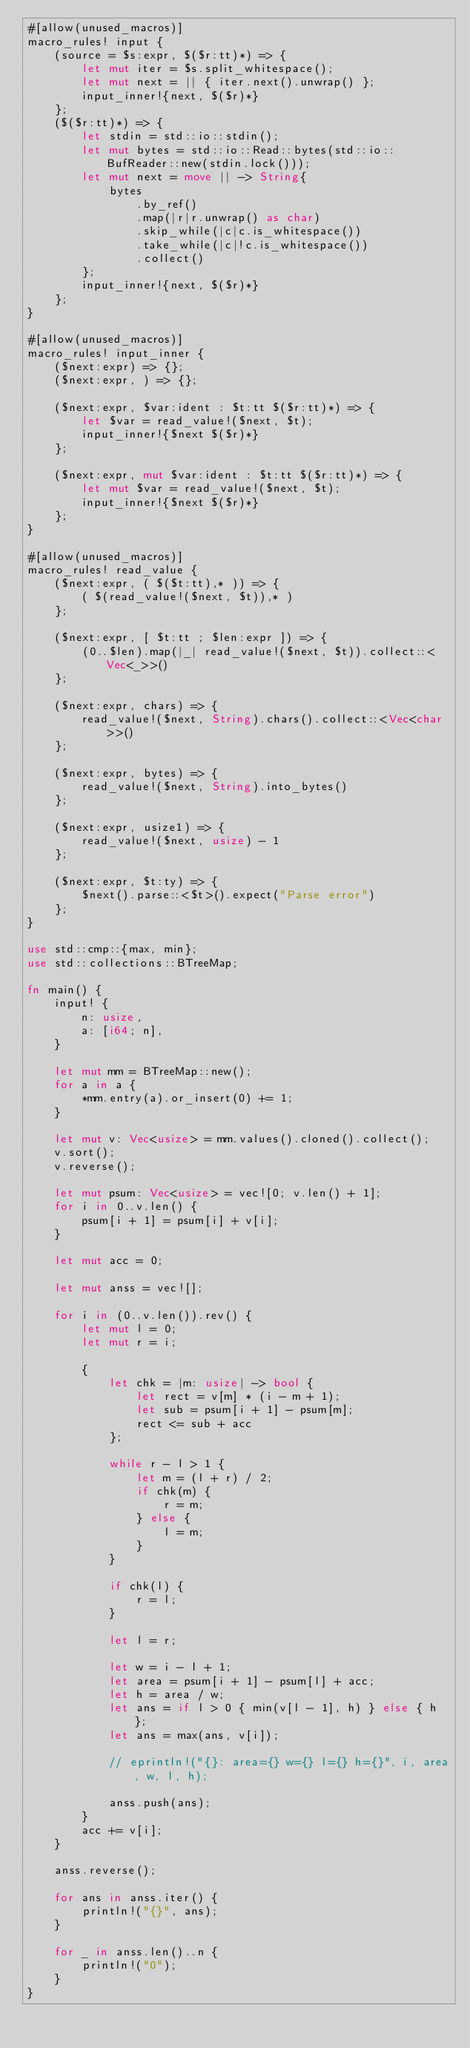<code> <loc_0><loc_0><loc_500><loc_500><_Rust_>#[allow(unused_macros)]
macro_rules! input {
    (source = $s:expr, $($r:tt)*) => {
        let mut iter = $s.split_whitespace();
        let mut next = || { iter.next().unwrap() };
        input_inner!{next, $($r)*}
    };
    ($($r:tt)*) => {
        let stdin = std::io::stdin();
        let mut bytes = std::io::Read::bytes(std::io::BufReader::new(stdin.lock()));
        let mut next = move || -> String{
            bytes
                .by_ref()
                .map(|r|r.unwrap() as char)
                .skip_while(|c|c.is_whitespace())
                .take_while(|c|!c.is_whitespace())
                .collect()
        };
        input_inner!{next, $($r)*}
    };
}

#[allow(unused_macros)]
macro_rules! input_inner {
    ($next:expr) => {};
    ($next:expr, ) => {};

    ($next:expr, $var:ident : $t:tt $($r:tt)*) => {
        let $var = read_value!($next, $t);
        input_inner!{$next $($r)*}
    };

    ($next:expr, mut $var:ident : $t:tt $($r:tt)*) => {
        let mut $var = read_value!($next, $t);
        input_inner!{$next $($r)*}
    };
}

#[allow(unused_macros)]
macro_rules! read_value {
    ($next:expr, ( $($t:tt),* )) => {
        ( $(read_value!($next, $t)),* )
    };

    ($next:expr, [ $t:tt ; $len:expr ]) => {
        (0..$len).map(|_| read_value!($next, $t)).collect::<Vec<_>>()
    };

    ($next:expr, chars) => {
        read_value!($next, String).chars().collect::<Vec<char>>()
    };

    ($next:expr, bytes) => {
        read_value!($next, String).into_bytes()
    };

    ($next:expr, usize1) => {
        read_value!($next, usize) - 1
    };

    ($next:expr, $t:ty) => {
        $next().parse::<$t>().expect("Parse error")
    };
}

use std::cmp::{max, min};
use std::collections::BTreeMap;

fn main() {
    input! {
        n: usize,
        a: [i64; n],
    }

    let mut mm = BTreeMap::new();
    for a in a {
        *mm.entry(a).or_insert(0) += 1;
    }

    let mut v: Vec<usize> = mm.values().cloned().collect();
    v.sort();
    v.reverse();

    let mut psum: Vec<usize> = vec![0; v.len() + 1];
    for i in 0..v.len() {
        psum[i + 1] = psum[i] + v[i];
    }

    let mut acc = 0;

    let mut anss = vec![];

    for i in (0..v.len()).rev() {
        let mut l = 0;
        let mut r = i;

        {
            let chk = |m: usize| -> bool {
                let rect = v[m] * (i - m + 1);
                let sub = psum[i + 1] - psum[m];
                rect <= sub + acc
            };

            while r - l > 1 {
                let m = (l + r) / 2;
                if chk(m) {
                    r = m;
                } else {
                    l = m;
                }
            }

            if chk(l) {
                r = l;
            }

            let l = r;

            let w = i - l + 1;
            let area = psum[i + 1] - psum[l] + acc;
            let h = area / w;
            let ans = if l > 0 { min(v[l - 1], h) } else { h };
            let ans = max(ans, v[i]);

            // eprintln!("{}: area={} w={} l={} h={}", i, area, w, l, h);

            anss.push(ans);
        }
        acc += v[i];
    }

    anss.reverse();

    for ans in anss.iter() {
        println!("{}", ans);
    }

    for _ in anss.len()..n {
        println!("0");
    }
}
</code> 